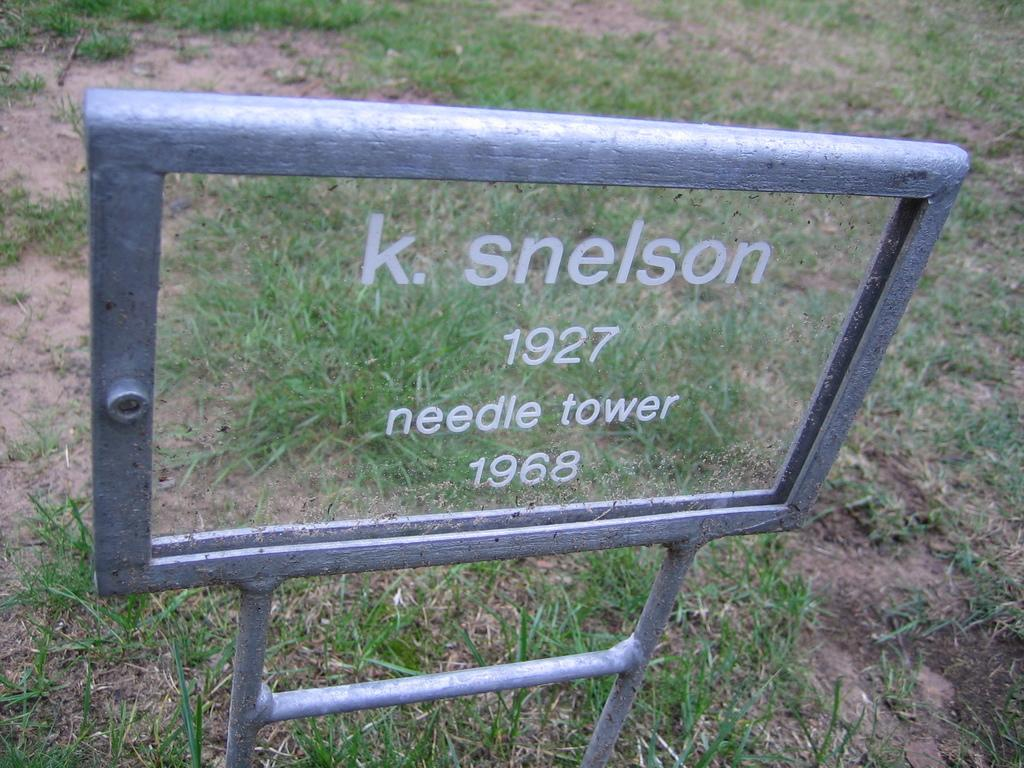What is the main object in the foreground of the image? There is a glass board in the foreground of the image. Are there any other glass boards visible in the image? Yes, there is more glass board around the glass board in the foreground. How many pigs can be seen playing with sugar on the glass board in the image? There are no pigs or sugar present in the image; it only features glass boards. 